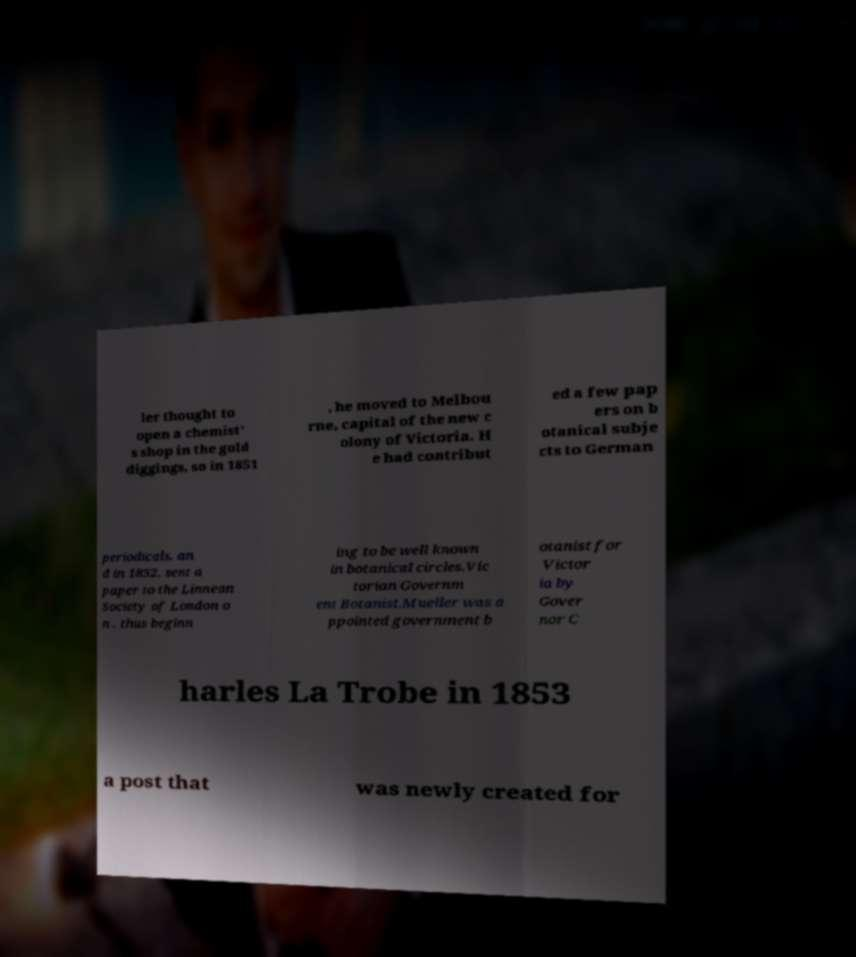Please identify and transcribe the text found in this image. ler thought to open a chemist' s shop in the gold diggings, so in 1851 , he moved to Melbou rne, capital of the new c olony of Victoria. H e had contribut ed a few pap ers on b otanical subje cts to German periodicals, an d in 1852, sent a paper to the Linnean Society of London o n , thus beginn ing to be well known in botanical circles.Vic torian Governm ent Botanist.Mueller was a ppointed government b otanist for Victor ia by Gover nor C harles La Trobe in 1853 a post that was newly created for 